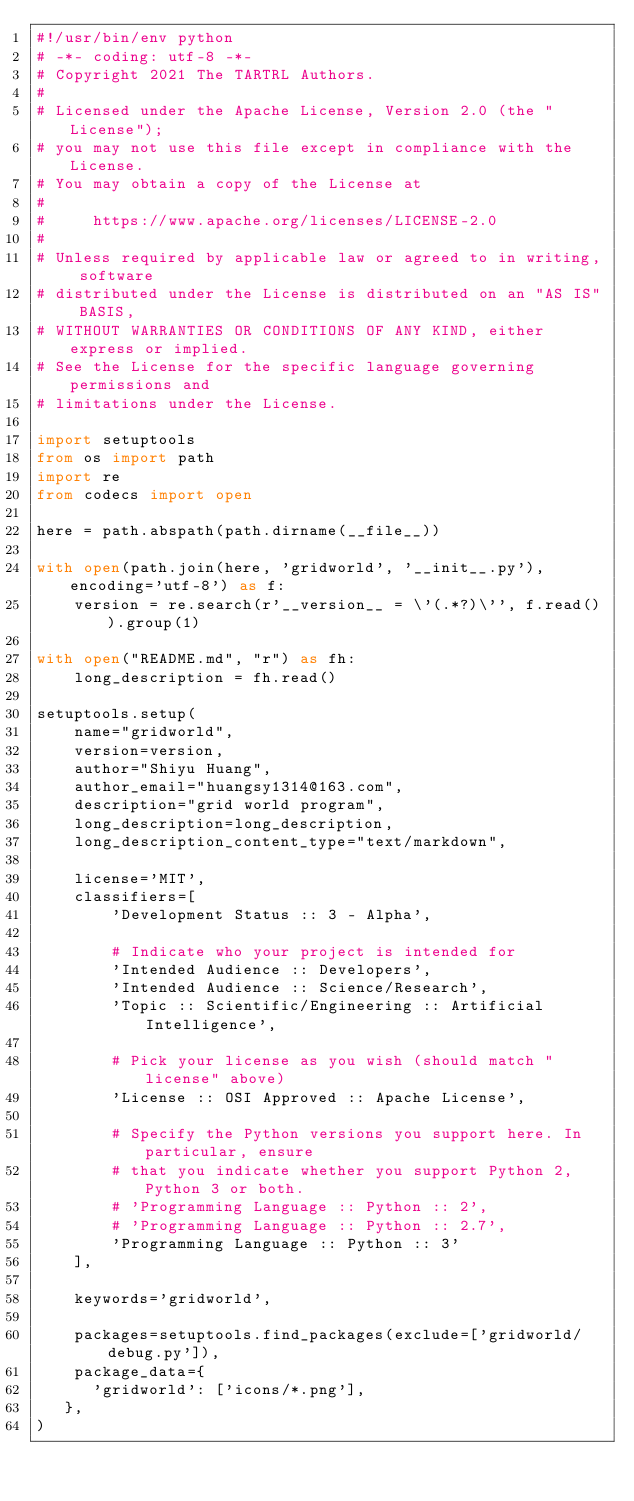<code> <loc_0><loc_0><loc_500><loc_500><_Python_>#!/usr/bin/env python
# -*- coding: utf-8 -*-
# Copyright 2021 The TARTRL Authors.
#
# Licensed under the Apache License, Version 2.0 (the "License");
# you may not use this file except in compliance with the License.
# You may obtain a copy of the License at
#
#     https://www.apache.org/licenses/LICENSE-2.0
#
# Unless required by applicable law or agreed to in writing, software
# distributed under the License is distributed on an "AS IS" BASIS,
# WITHOUT WARRANTIES OR CONDITIONS OF ANY KIND, either express or implied.
# See the License for the specific language governing permissions and
# limitations under the License.

import setuptools
from os import path
import re
from codecs import open

here = path.abspath(path.dirname(__file__))

with open(path.join(here, 'gridworld', '__init__.py'), encoding='utf-8') as f:
    version = re.search(r'__version__ = \'(.*?)\'', f.read()).group(1)

with open("README.md", "r") as fh:
    long_description = fh.read()

setuptools.setup(
    name="gridworld",
    version=version,
    author="Shiyu Huang",
    author_email="huangsy1314@163.com",
    description="grid world program",
    long_description=long_description,
    long_description_content_type="text/markdown",

    license='MIT',
    classifiers=[
        'Development Status :: 3 - Alpha',

        # Indicate who your project is intended for
        'Intended Audience :: Developers',
        'Intended Audience :: Science/Research',
        'Topic :: Scientific/Engineering :: Artificial Intelligence',

        # Pick your license as you wish (should match "license" above)
        'License :: OSI Approved :: Apache License',

        # Specify the Python versions you support here. In particular, ensure
        # that you indicate whether you support Python 2, Python 3 or both.
        # 'Programming Language :: Python :: 2',
        # 'Programming Language :: Python :: 2.7',
        'Programming Language :: Python :: 3'
    ],

    keywords='gridworld',

    packages=setuptools.find_packages(exclude=['gridworld/debug.py']),
    package_data={
      'gridworld': ['icons/*.png'],
   },
)   
</code> 